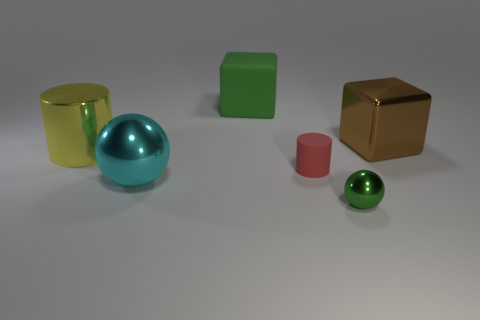There is a object that is the same color as the small ball; what is its shape?
Ensure brevity in your answer.  Cube. There is a large object that is left of the big cyan metal sphere; does it have the same color as the shiny sphere on the left side of the tiny matte cylinder?
Offer a very short reply. No. How many small objects are in front of the tiny metallic object?
Provide a succinct answer. 0. What size is the shiny thing that is the same color as the large rubber object?
Your answer should be very brief. Small. Is there a yellow metal object of the same shape as the big brown metallic object?
Make the answer very short. No. What color is the metallic cylinder that is the same size as the green block?
Provide a succinct answer. Yellow. Is the number of small red cylinders that are in front of the yellow shiny cylinder less than the number of cyan things behind the red matte cylinder?
Give a very brief answer. No. There is a cube on the left side of the brown shiny block; is it the same size as the big cyan sphere?
Ensure brevity in your answer.  Yes. What shape is the green thing to the right of the big green matte cube?
Make the answer very short. Sphere. Are there more cubes than large cyan metallic balls?
Offer a very short reply. Yes. 